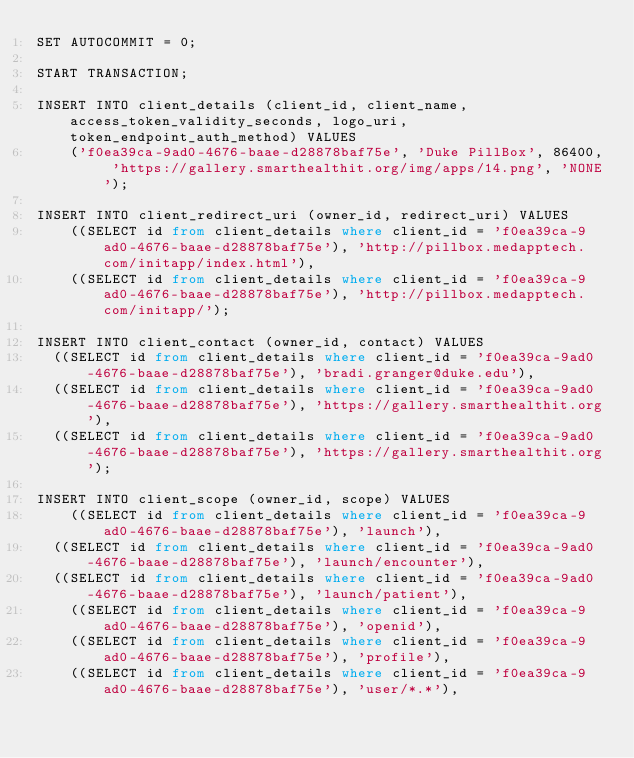Convert code to text. <code><loc_0><loc_0><loc_500><loc_500><_SQL_>SET AUTOCOMMIT = 0;

START TRANSACTION;

INSERT INTO client_details (client_id, client_name, access_token_validity_seconds, logo_uri, token_endpoint_auth_method) VALUES
	('f0ea39ca-9ad0-4676-baae-d28878baf75e', 'Duke PillBox', 86400, 'https://gallery.smarthealthit.org/img/apps/14.png', 'NONE');

INSERT INTO client_redirect_uri (owner_id, redirect_uri) VALUES
	((SELECT id from client_details where client_id = 'f0ea39ca-9ad0-4676-baae-d28878baf75e'), 'http://pillbox.medapptech.com/initapp/index.html'),
	((SELECT id from client_details where client_id = 'f0ea39ca-9ad0-4676-baae-d28878baf75e'), 'http://pillbox.medapptech.com/initapp/');

INSERT INTO client_contact (owner_id, contact) VALUES
  ((SELECT id from client_details where client_id = 'f0ea39ca-9ad0-4676-baae-d28878baf75e'), 'bradi.granger@duke.edu'),
  ((SELECT id from client_details where client_id = 'f0ea39ca-9ad0-4676-baae-d28878baf75e'), 'https://gallery.smarthealthit.org'),
  ((SELECT id from client_details where client_id = 'f0ea39ca-9ad0-4676-baae-d28878baf75e'), 'https://gallery.smarthealthit.org');

INSERT INTO client_scope (owner_id, scope) VALUES
	((SELECT id from client_details where client_id = 'f0ea39ca-9ad0-4676-baae-d28878baf75e'), 'launch'),
  ((SELECT id from client_details where client_id = 'f0ea39ca-9ad0-4676-baae-d28878baf75e'), 'launch/encounter'),
  ((SELECT id from client_details where client_id = 'f0ea39ca-9ad0-4676-baae-d28878baf75e'), 'launch/patient'),
	((SELECT id from client_details where client_id = 'f0ea39ca-9ad0-4676-baae-d28878baf75e'), 'openid'),
	((SELECT id from client_details where client_id = 'f0ea39ca-9ad0-4676-baae-d28878baf75e'), 'profile'),
	((SELECT id from client_details where client_id = 'f0ea39ca-9ad0-4676-baae-d28878baf75e'), 'user/*.*'),</code> 